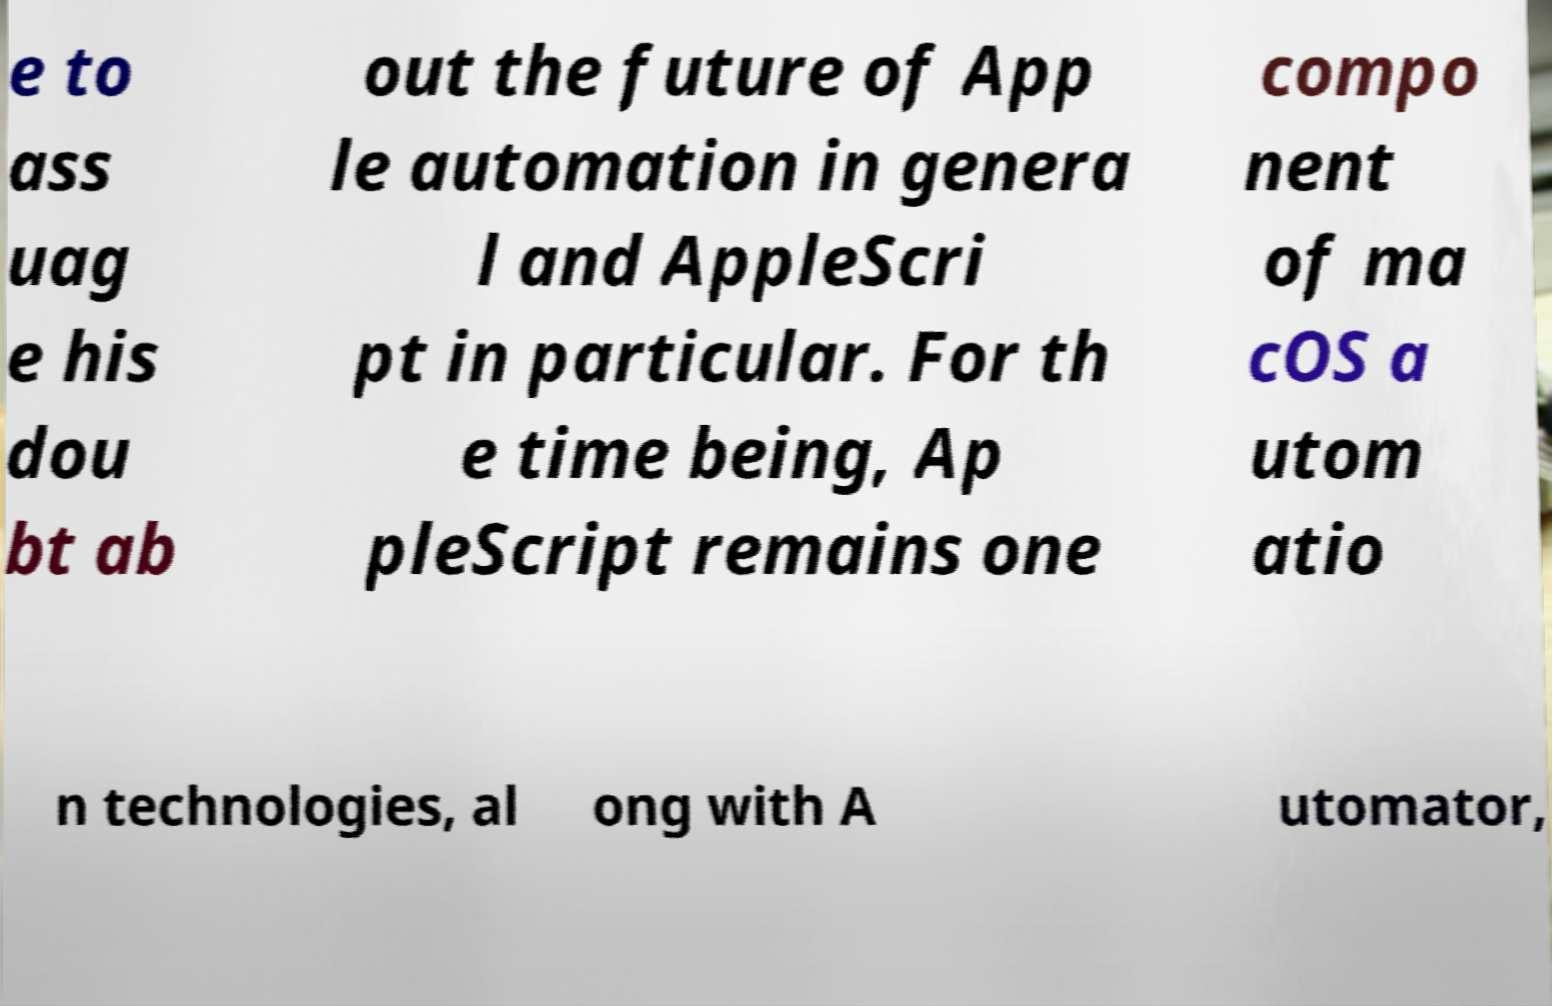Can you accurately transcribe the text from the provided image for me? e to ass uag e his dou bt ab out the future of App le automation in genera l and AppleScri pt in particular. For th e time being, Ap pleScript remains one compo nent of ma cOS a utom atio n technologies, al ong with A utomator, 